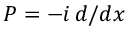<formula> <loc_0><loc_0><loc_500><loc_500>P = - i \, d / d x</formula> 